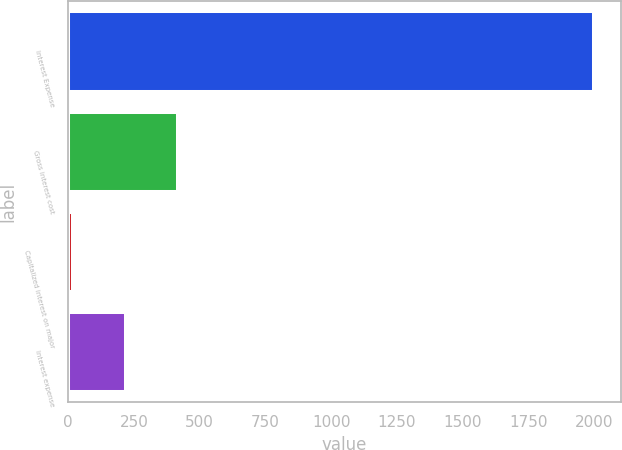Convert chart to OTSL. <chart><loc_0><loc_0><loc_500><loc_500><bar_chart><fcel>Interest Expense<fcel>Gross interest cost<fcel>Capitalized interest on major<fcel>Interest expense<nl><fcel>2001<fcel>415.88<fcel>19.6<fcel>217.74<nl></chart> 